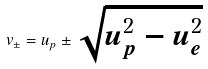<formula> <loc_0><loc_0><loc_500><loc_500>v _ { \pm } = u _ { p } \pm \sqrt { u _ { p } ^ { 2 } - u _ { e } ^ { 2 } }</formula> 